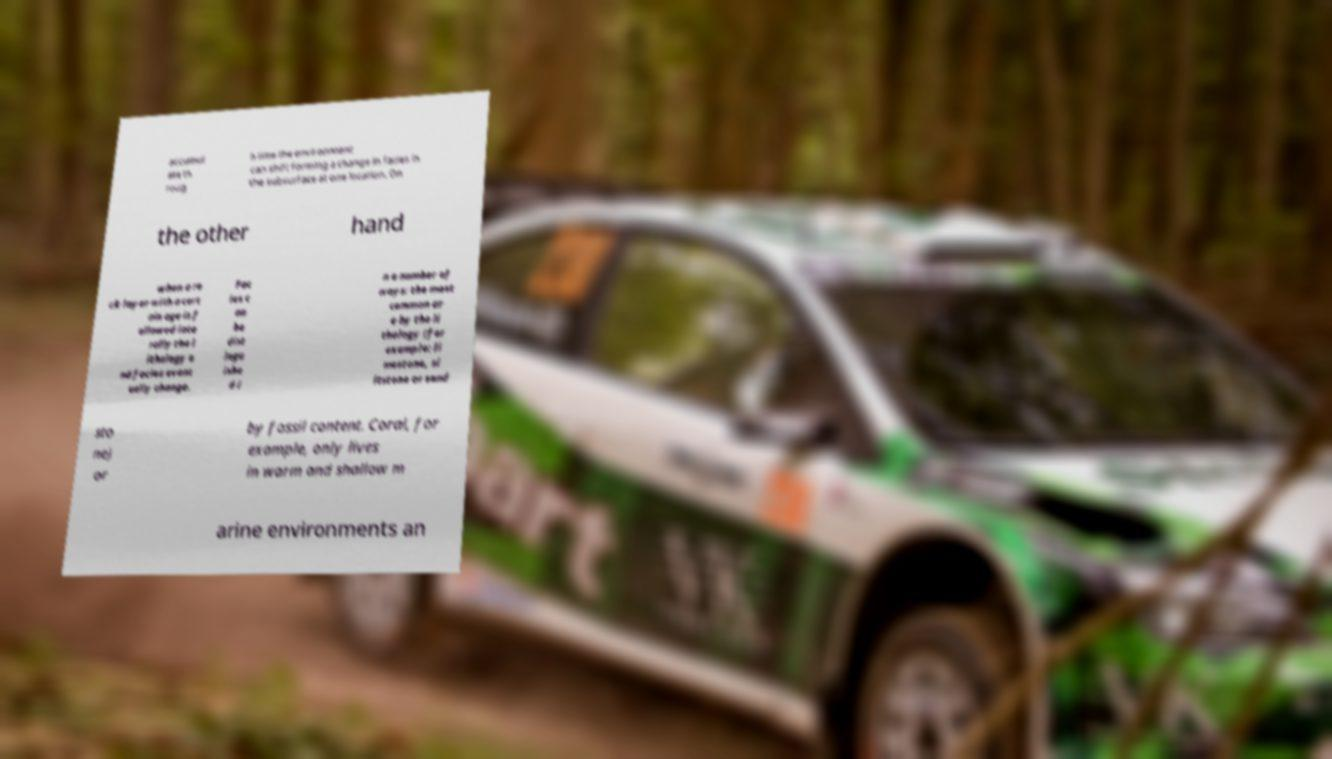I need the written content from this picture converted into text. Can you do that? accumul ate th roug h time the environment can shift forming a change in facies in the subsurface at one location. On the other hand when a ro ck layer with a cert ain age is f ollowed late rally the l ithology a nd facies event ually change. Fac ies c an be dist ingu ishe d i n a number of ways: the most common ar e by the li thology (for example: li mestone, si ltstone or sand sto ne) or by fossil content. Coral, for example, only lives in warm and shallow m arine environments an 